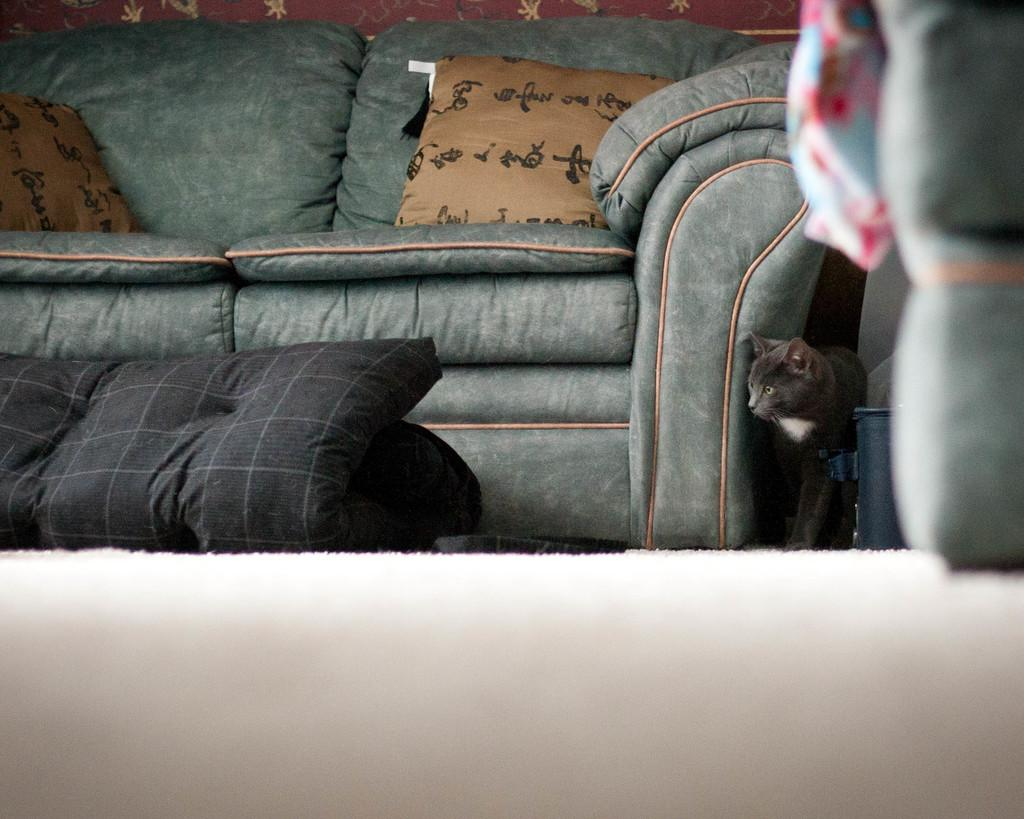What type of furniture is in the image? There is a green sofa in the image. How many cushions are placed on the green sofa? Two cushions are placed on the green sofa. What animal is beside the sofa? There is a black cat beside the sofa. What other piece of furniture can be seen in the image? There is a black bed in the image. What type of jar is being used to create thunder in the image? There is no jar or thunder present in the image. 